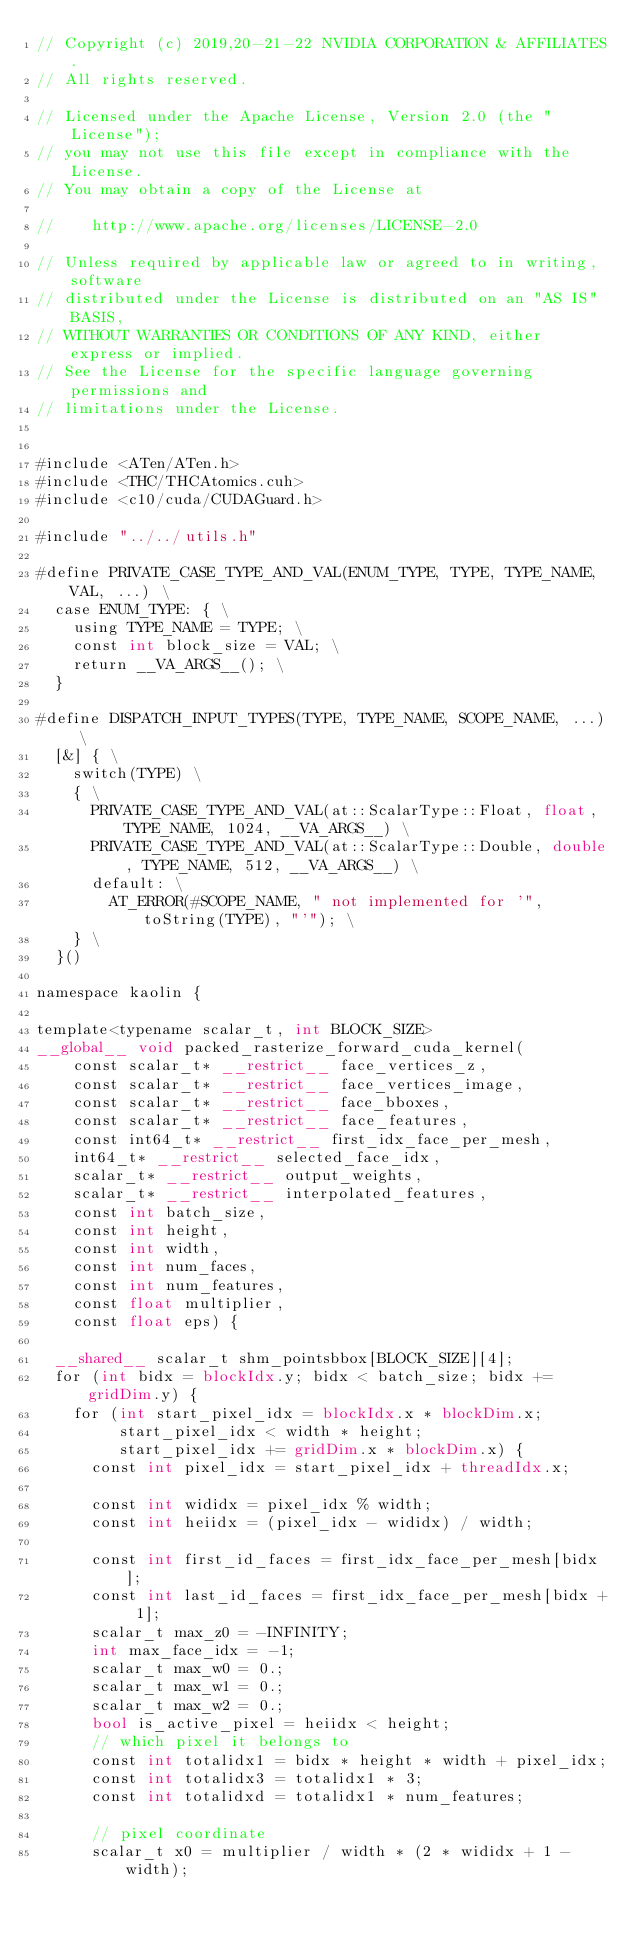<code> <loc_0><loc_0><loc_500><loc_500><_Cuda_>// Copyright (c) 2019,20-21-22 NVIDIA CORPORATION & AFFILIATES.
// All rights reserved.

// Licensed under the Apache License, Version 2.0 (the "License");
// you may not use this file except in compliance with the License.
// You may obtain a copy of the License at

//    http://www.apache.org/licenses/LICENSE-2.0

// Unless required by applicable law or agreed to in writing, software
// distributed under the License is distributed on an "AS IS" BASIS,
// WITHOUT WARRANTIES OR CONDITIONS OF ANY KIND, either express or implied.
// See the License for the specific language governing permissions and
// limitations under the License.


#include <ATen/ATen.h>
#include <THC/THCAtomics.cuh>
#include <c10/cuda/CUDAGuard.h>

#include "../../utils.h"

#define PRIVATE_CASE_TYPE_AND_VAL(ENUM_TYPE, TYPE, TYPE_NAME, VAL, ...) \
  case ENUM_TYPE: { \
    using TYPE_NAME = TYPE; \
    const int block_size = VAL; \
    return __VA_ARGS__(); \
  }

#define DISPATCH_INPUT_TYPES(TYPE, TYPE_NAME, SCOPE_NAME, ...) \
  [&] { \
    switch(TYPE) \
    { \
      PRIVATE_CASE_TYPE_AND_VAL(at::ScalarType::Float, float, TYPE_NAME, 1024, __VA_ARGS__) \
      PRIVATE_CASE_TYPE_AND_VAL(at::ScalarType::Double, double, TYPE_NAME, 512, __VA_ARGS__) \
      default: \
        AT_ERROR(#SCOPE_NAME, " not implemented for '", toString(TYPE), "'"); \
    } \
  }()

namespace kaolin {

template<typename scalar_t, int BLOCK_SIZE>
__global__ void packed_rasterize_forward_cuda_kernel(
    const scalar_t* __restrict__ face_vertices_z,
    const scalar_t* __restrict__ face_vertices_image,
    const scalar_t* __restrict__ face_bboxes,
    const scalar_t* __restrict__ face_features,
    const int64_t* __restrict__ first_idx_face_per_mesh,
    int64_t* __restrict__ selected_face_idx,
    scalar_t* __restrict__ output_weights,
    scalar_t* __restrict__ interpolated_features,
    const int batch_size,
    const int height,
    const int width,
    const int num_faces,
    const int num_features,
    const float multiplier,
    const float eps) {

  __shared__ scalar_t shm_pointsbbox[BLOCK_SIZE][4];
  for (int bidx = blockIdx.y; bidx < batch_size; bidx += gridDim.y) {
    for (int start_pixel_idx = blockIdx.x * blockDim.x;
         start_pixel_idx < width * height;
         start_pixel_idx += gridDim.x * blockDim.x) {
      const int pixel_idx = start_pixel_idx + threadIdx.x;

      const int wididx = pixel_idx % width;
      const int heiidx = (pixel_idx - wididx) / width;

      const int first_id_faces = first_idx_face_per_mesh[bidx];
      const int last_id_faces = first_idx_face_per_mesh[bidx + 1];
      scalar_t max_z0 = -INFINITY;
      int max_face_idx = -1;
      scalar_t max_w0 = 0.;
      scalar_t max_w1 = 0.;
      scalar_t max_w2 = 0.;
      bool is_active_pixel = heiidx < height;
      // which pixel it belongs to
      const int totalidx1 = bidx * height * width + pixel_idx;
      const int totalidx3 = totalidx1 * 3;
      const int totalidxd = totalidx1 * num_features;

      // pixel coordinate
      scalar_t x0 = multiplier / width * (2 * wididx + 1 - width);</code> 